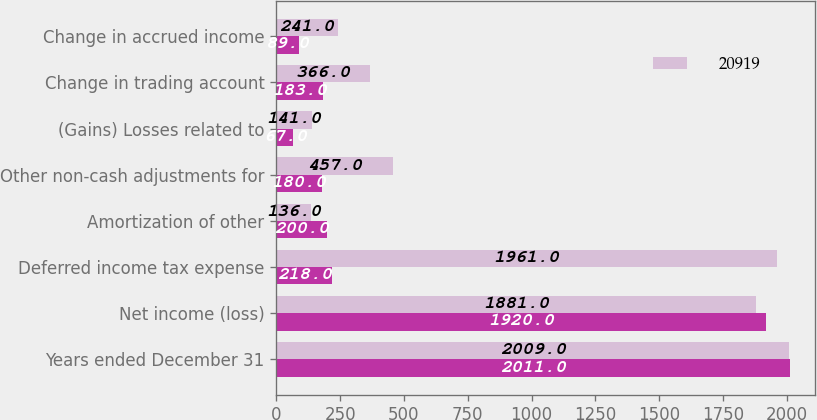Convert chart to OTSL. <chart><loc_0><loc_0><loc_500><loc_500><stacked_bar_chart><ecel><fcel>Years ended December 31<fcel>Net income (loss)<fcel>Deferred income tax expense<fcel>Amortization of other<fcel>Other non-cash adjustments for<fcel>(Gains) Losses related to<fcel>Change in trading account<fcel>Change in accrued income<nl><fcel>nan<fcel>2011<fcel>1920<fcel>218<fcel>200<fcel>180<fcel>67<fcel>183<fcel>89<nl><fcel>20919<fcel>2009<fcel>1881<fcel>1961<fcel>136<fcel>457<fcel>141<fcel>366<fcel>241<nl></chart> 